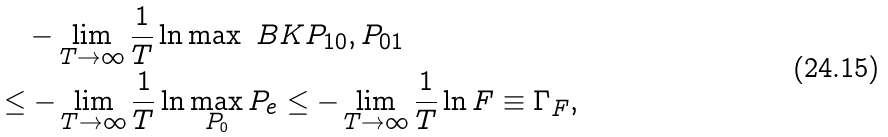Convert formula to latex. <formula><loc_0><loc_0><loc_500><loc_500>& \quad - \lim _ { T \to \infty } \frac { 1 } { T } \ln \max \ B K { P _ { 1 0 } , P _ { 0 1 } } \\ & \leq - \lim _ { T \to \infty } \frac { 1 } { T } \ln \max _ { P _ { 0 } } P _ { e } \leq - \lim _ { T \to \infty } \frac { 1 } { T } \ln F \equiv \Gamma _ { F } ,</formula> 